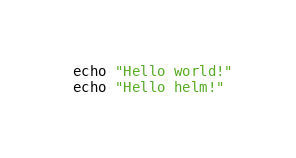<code> <loc_0><loc_0><loc_500><loc_500><_Bash_>echo "Hello world!"
echo "Hello helm!"</code> 